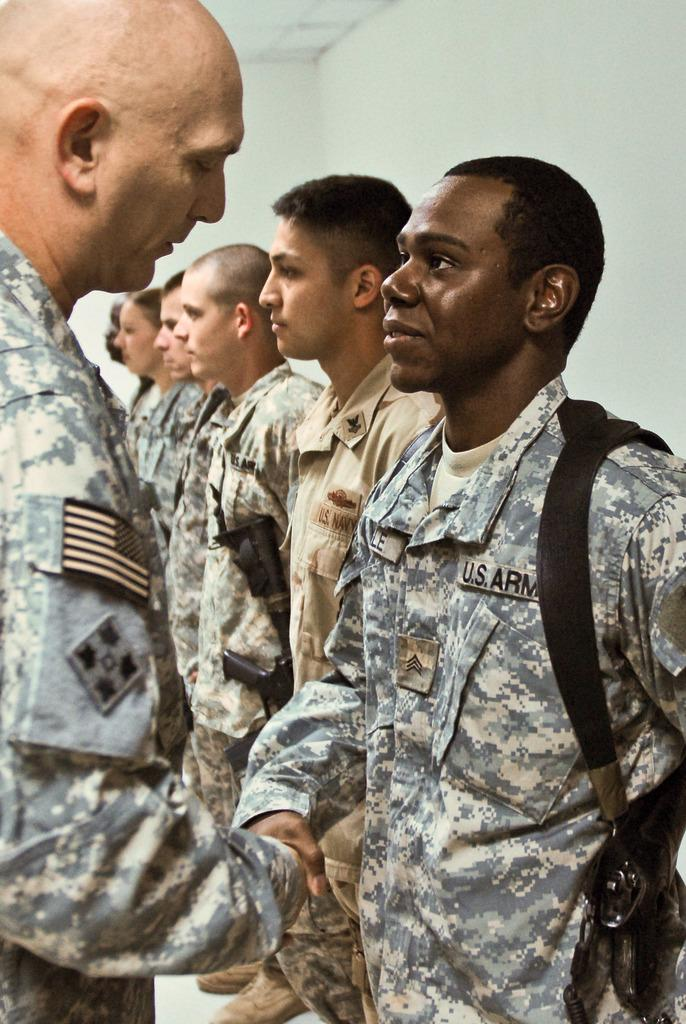What are the persons in the image wearing? The persons in the image are wearing uniforms. What are the persons doing in the image? The persons are standing. What can be seen in the background of the image? There is a white-colored wall and a ceiling visible in the background of the image. What type of trousers is the girl wearing in the image? There is no girl present in the image, and therefore no information about her trousers can be provided. 